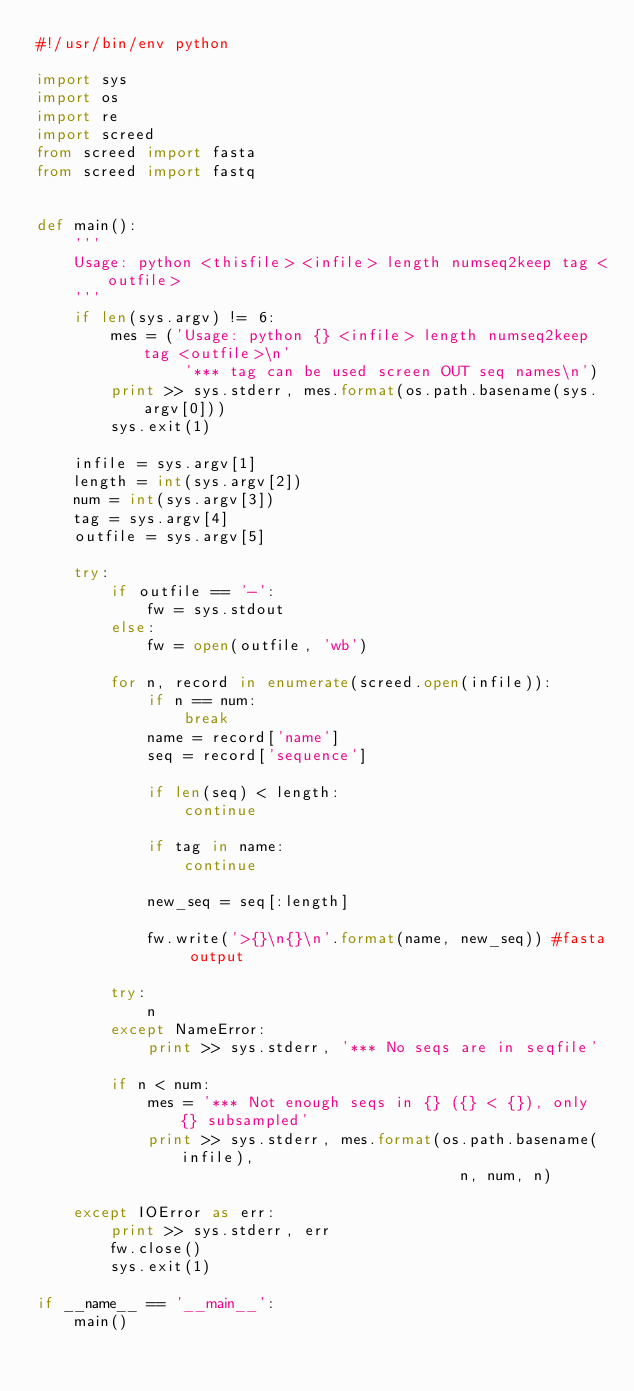<code> <loc_0><loc_0><loc_500><loc_500><_Python_>#!/usr/bin/env python

import sys
import os
import re
import screed
from screed import fasta
from screed import fastq


def main():
    '''
    Usage: python <thisfile> <infile> length numseq2keep tag <outfile>
    '''
    if len(sys.argv) != 6:
        mes = ('Usage: python {} <infile> length numseq2keep tag <outfile>\n'
                '*** tag can be used screen OUT seq names\n')
        print >> sys.stderr, mes.format(os.path.basename(sys.argv[0]))
        sys.exit(1)

    infile = sys.argv[1]
    length = int(sys.argv[2])
    num = int(sys.argv[3])
    tag = sys.argv[4]
    outfile = sys.argv[5]

    try:
        if outfile == '-':
            fw = sys.stdout
        else:
            fw = open(outfile, 'wb')

        for n, record in enumerate(screed.open(infile)):
            if n == num:
                break
            name = record['name']
            seq = record['sequence']

            if len(seq) < length:
                continue

            if tag in name:
                continue

            new_seq = seq[:length]

            fw.write('>{}\n{}\n'.format(name, new_seq)) #fasta output

        try:
            n
        except NameError:
            print >> sys.stderr, '*** No seqs are in seqfile'

        if n < num:
            mes = '*** Not enough seqs in {} ({} < {}), only {} subsampled'
            print >> sys.stderr, mes.format(os.path.basename(infile),
                                              n, num, n)

    except IOError as err:
        print >> sys.stderr, err
        fw.close()
        sys.exit(1)

if __name__ == '__main__':
    main()
</code> 